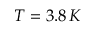Convert formula to latex. <formula><loc_0><loc_0><loc_500><loc_500>T = 3 . 8 \, K</formula> 